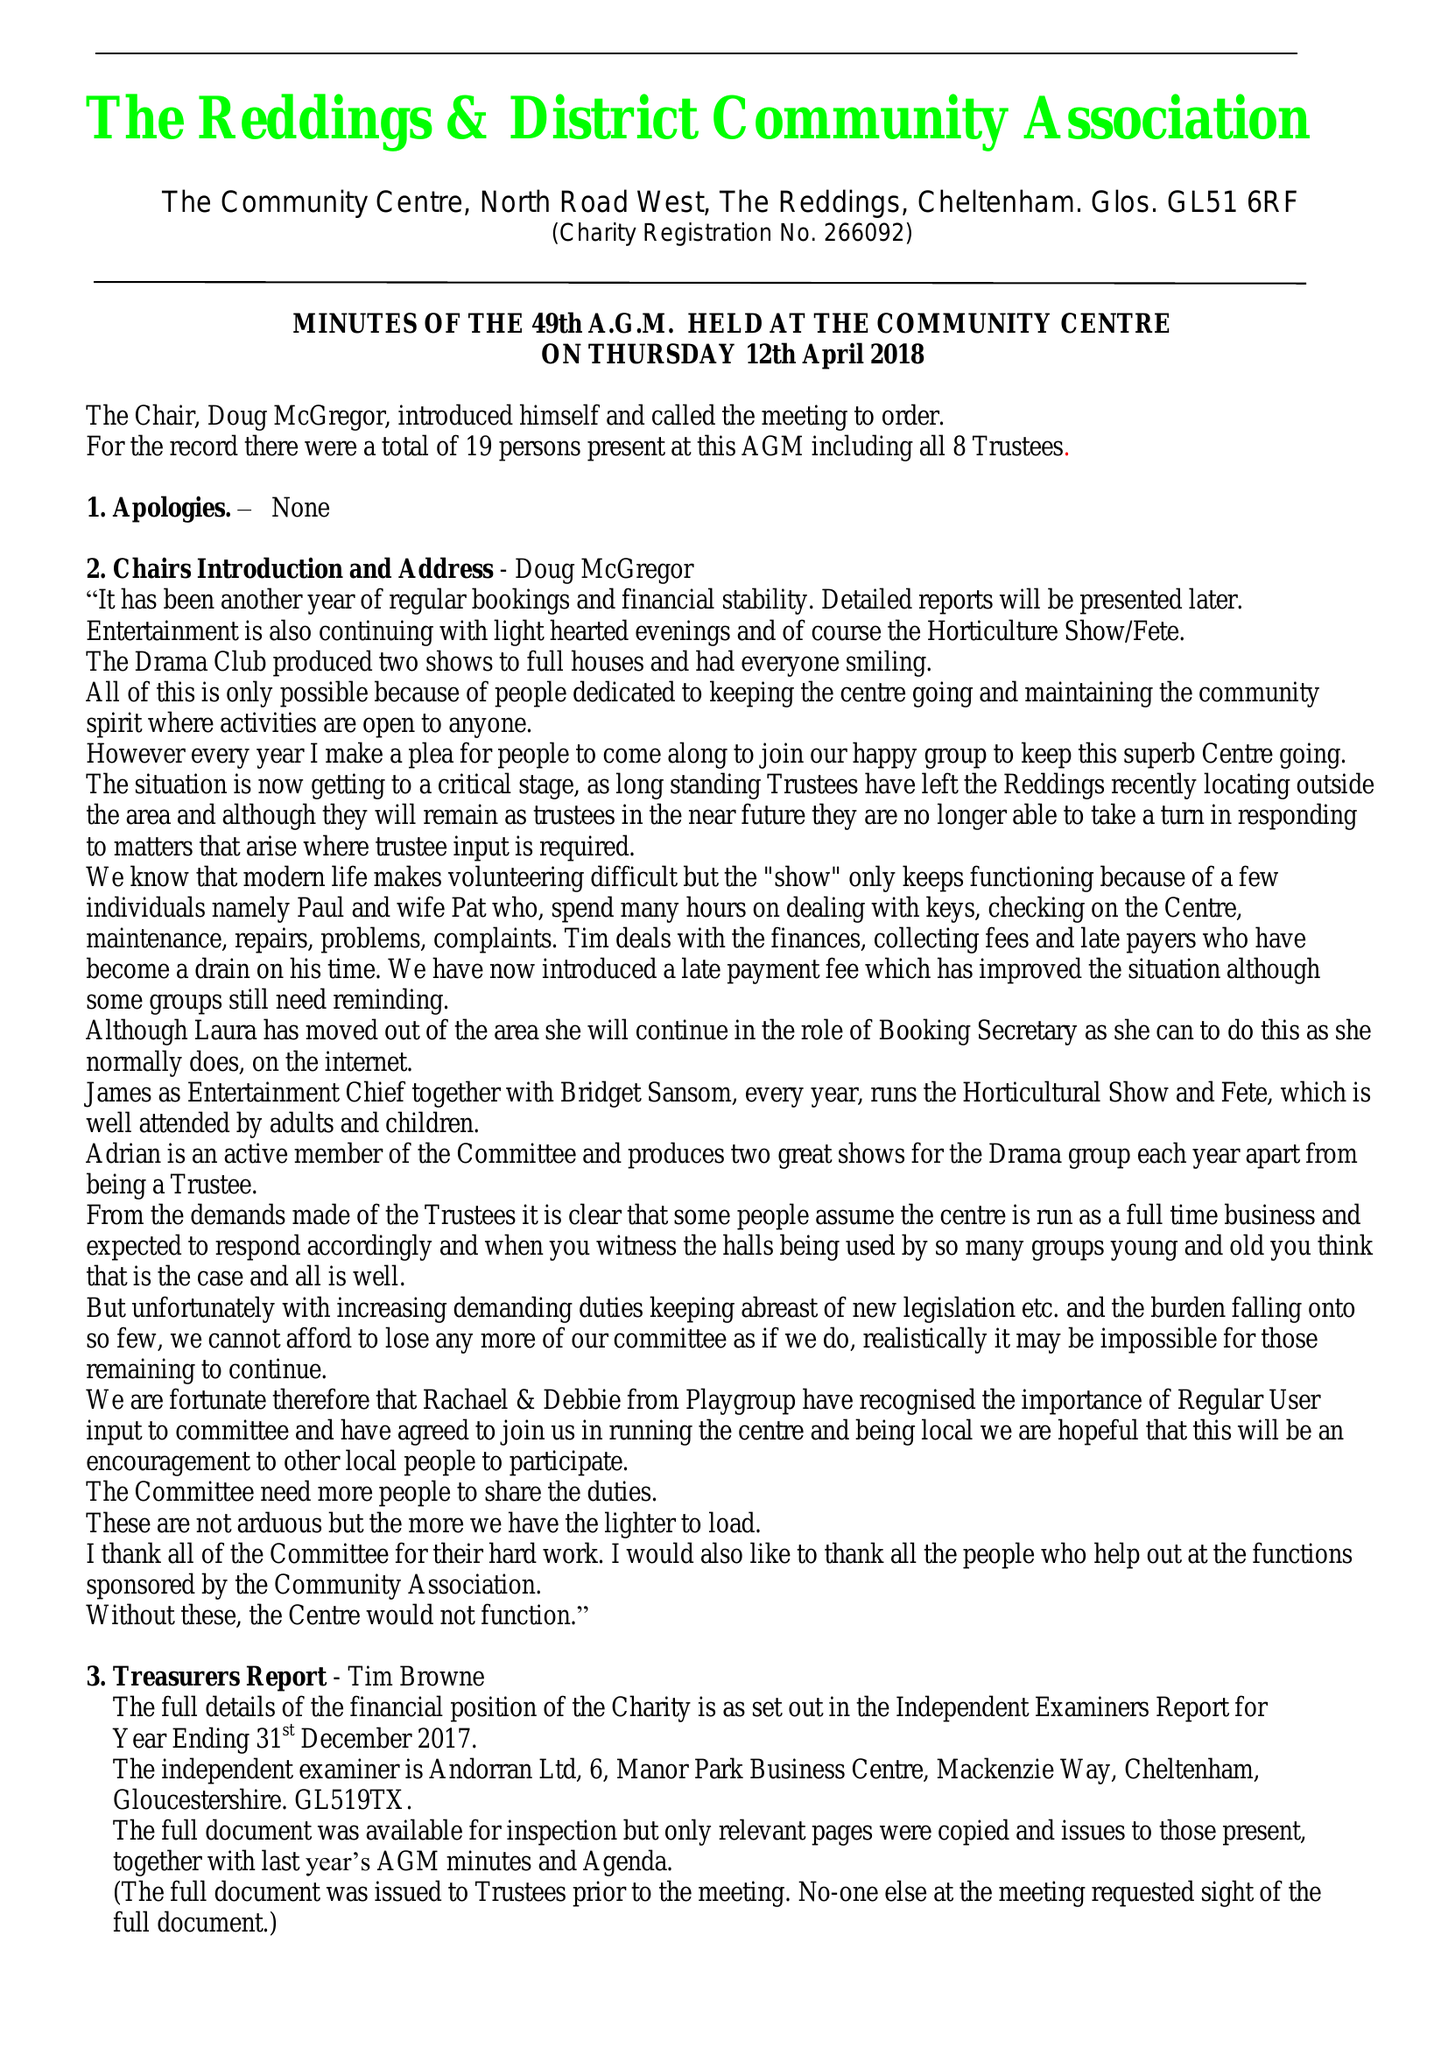What is the value for the address__postcode?
Answer the question using a single word or phrase. GL51 6RF 